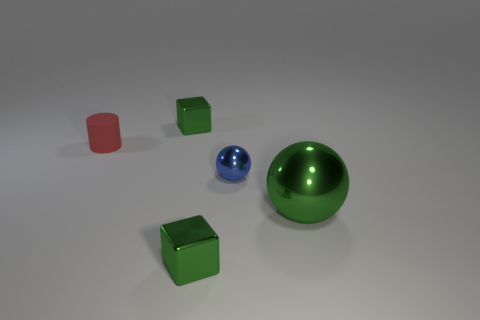Add 1 big balls. How many objects exist? 6 Subtract all cylinders. How many objects are left? 4 Subtract all gray shiny cylinders. Subtract all green things. How many objects are left? 2 Add 4 small metal cubes. How many small metal cubes are left? 6 Add 1 balls. How many balls exist? 3 Subtract 0 cyan balls. How many objects are left? 5 